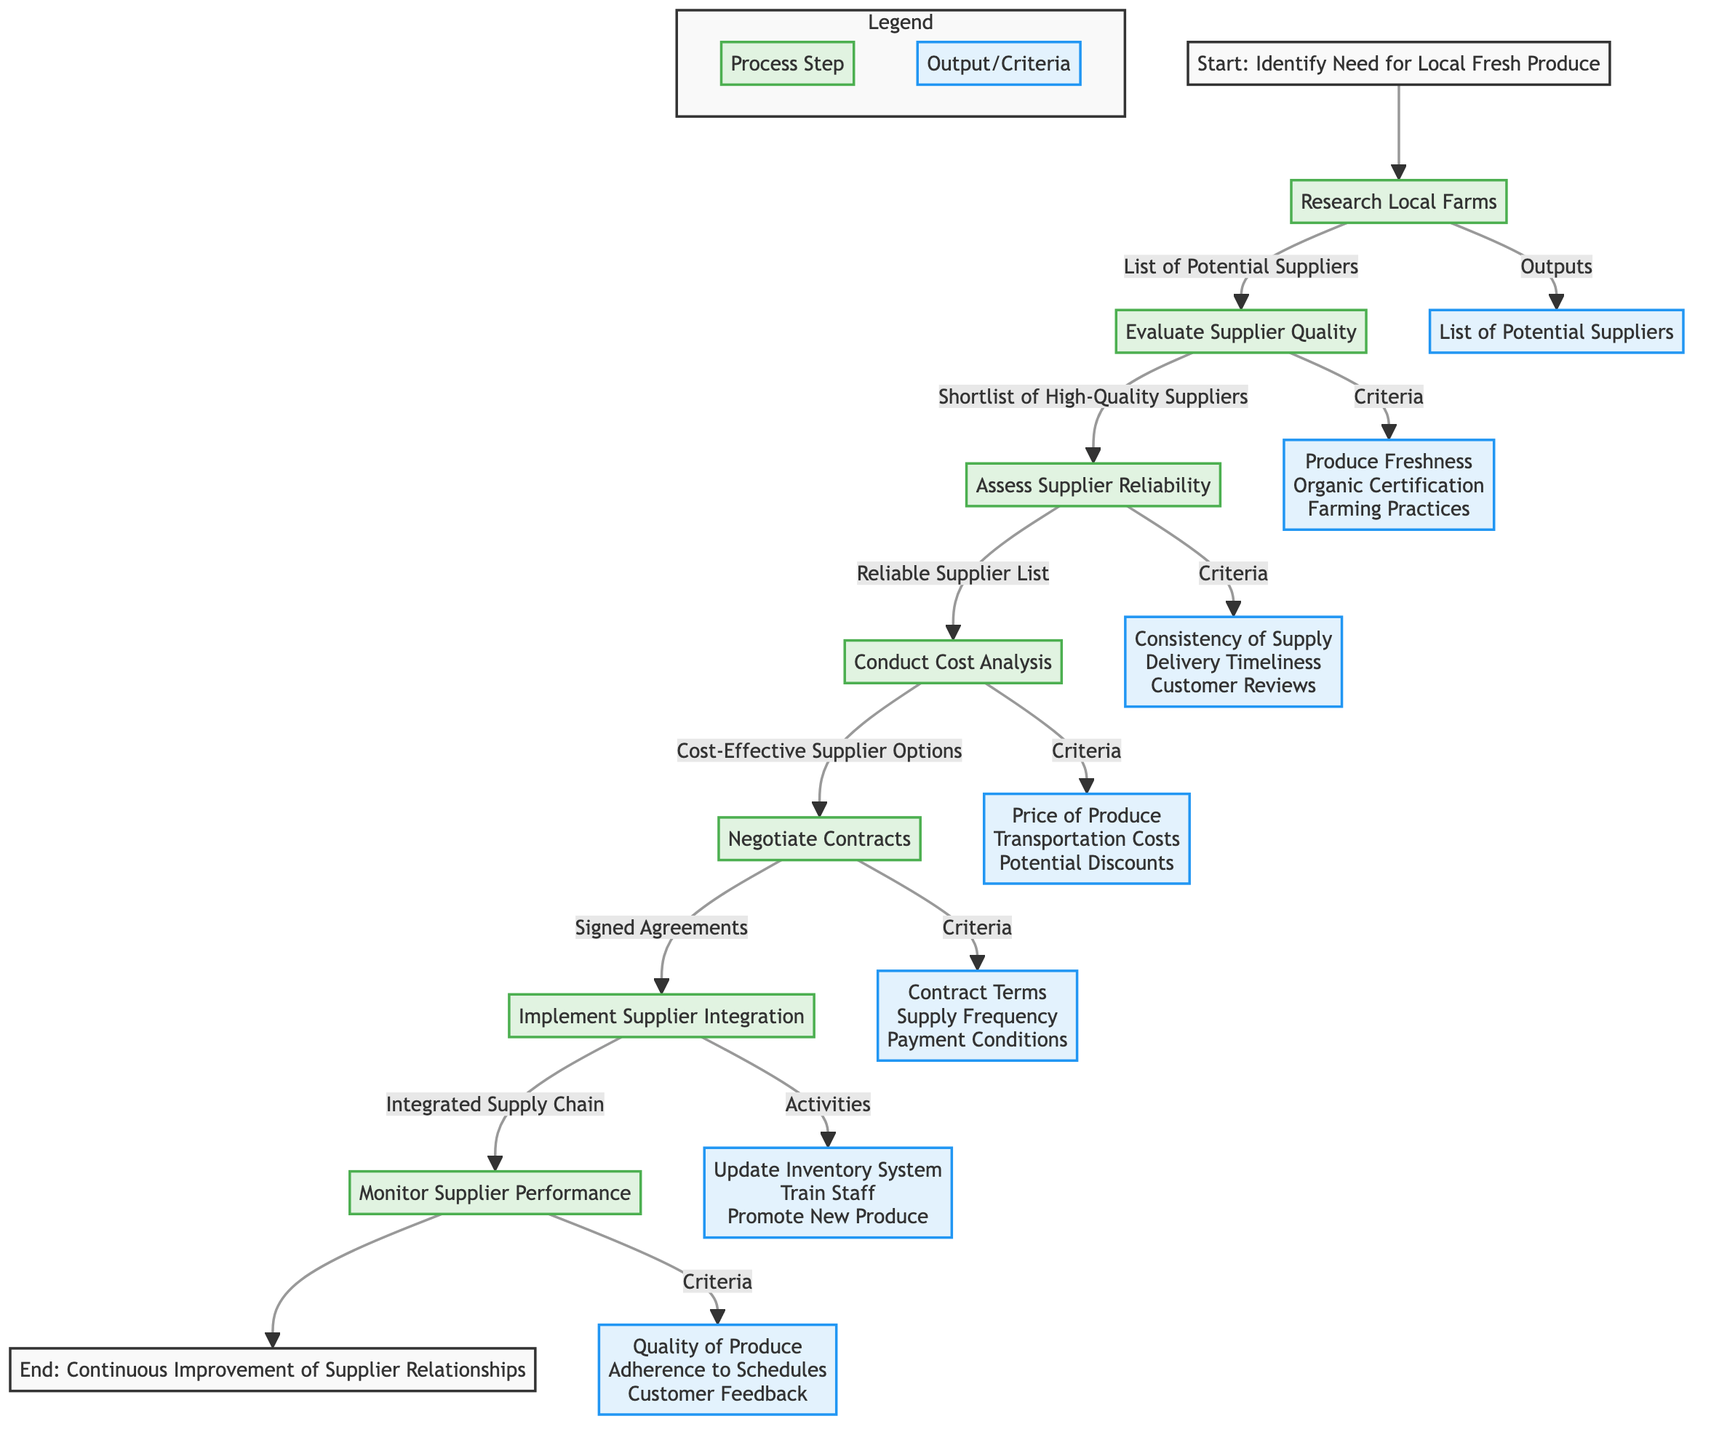What is the first step in the process? The diagram starts with the node labeled "Identify Need for Local Fresh Produce" which indicates the initial action to be taken in the process.
Answer: Identify Need for Local Fresh Produce How many criteria are considered when evaluating supplier quality? The diagram lists three specific criteria for evaluating supplier quality: Produce Freshness, Organic Certification, and Farming Practices, which can be counted.
Answer: Three What is the output of the "Assess Supplier Reliability" step? After completing the "Assess Supplier Reliability" step, the output generated is identified as "Reliable Supplier List" according to the diagram flow.
Answer: Reliable Supplier List Which step comes before conducting the cost analysis? The step that occurs just prior to "Conduct Cost Analysis" is "Assess Supplier Reliability," indicating the sequence of actions in the flowchart.
Answer: Assess Supplier Reliability What outputs are generated by the "Implement Supplier Integration" step? The outputs specified for the "Implement Supplier Integration" step include "Integrated Supply Chain," indicating the result of activities performed in this step.
Answer: Integrated Supply Chain How many outputs are identified in the "Research Local Farms" step? The "Research Local Farms" step outputs a single item, which is the "List of Potential Suppliers," as shown in the flow diagram.
Answer: One What criteria are used in the "Conduct Cost Analysis" step? The diagram specifies three criteria considered in the "Conduct Cost Analysis": Price of Produce, Transportation Costs, and Potential Discounts for Bulk Buys.
Answer: Price of Produce, Transportation Costs, Potential Discounts What is the purpose of the "Monitor Supplier Performance" step? This step is aimed at generating "Supplier Performance Reports," which reflects the effectiveness and quality of the suppliers based on various evaluations.
Answer: Supplier Performance Reports What happens after "Negotiate Contracts"? The next action following "Negotiate Contracts" is "Implement Supplier Integration," indicating the flow of steps following contract completion.
Answer: Implement Supplier Integration 